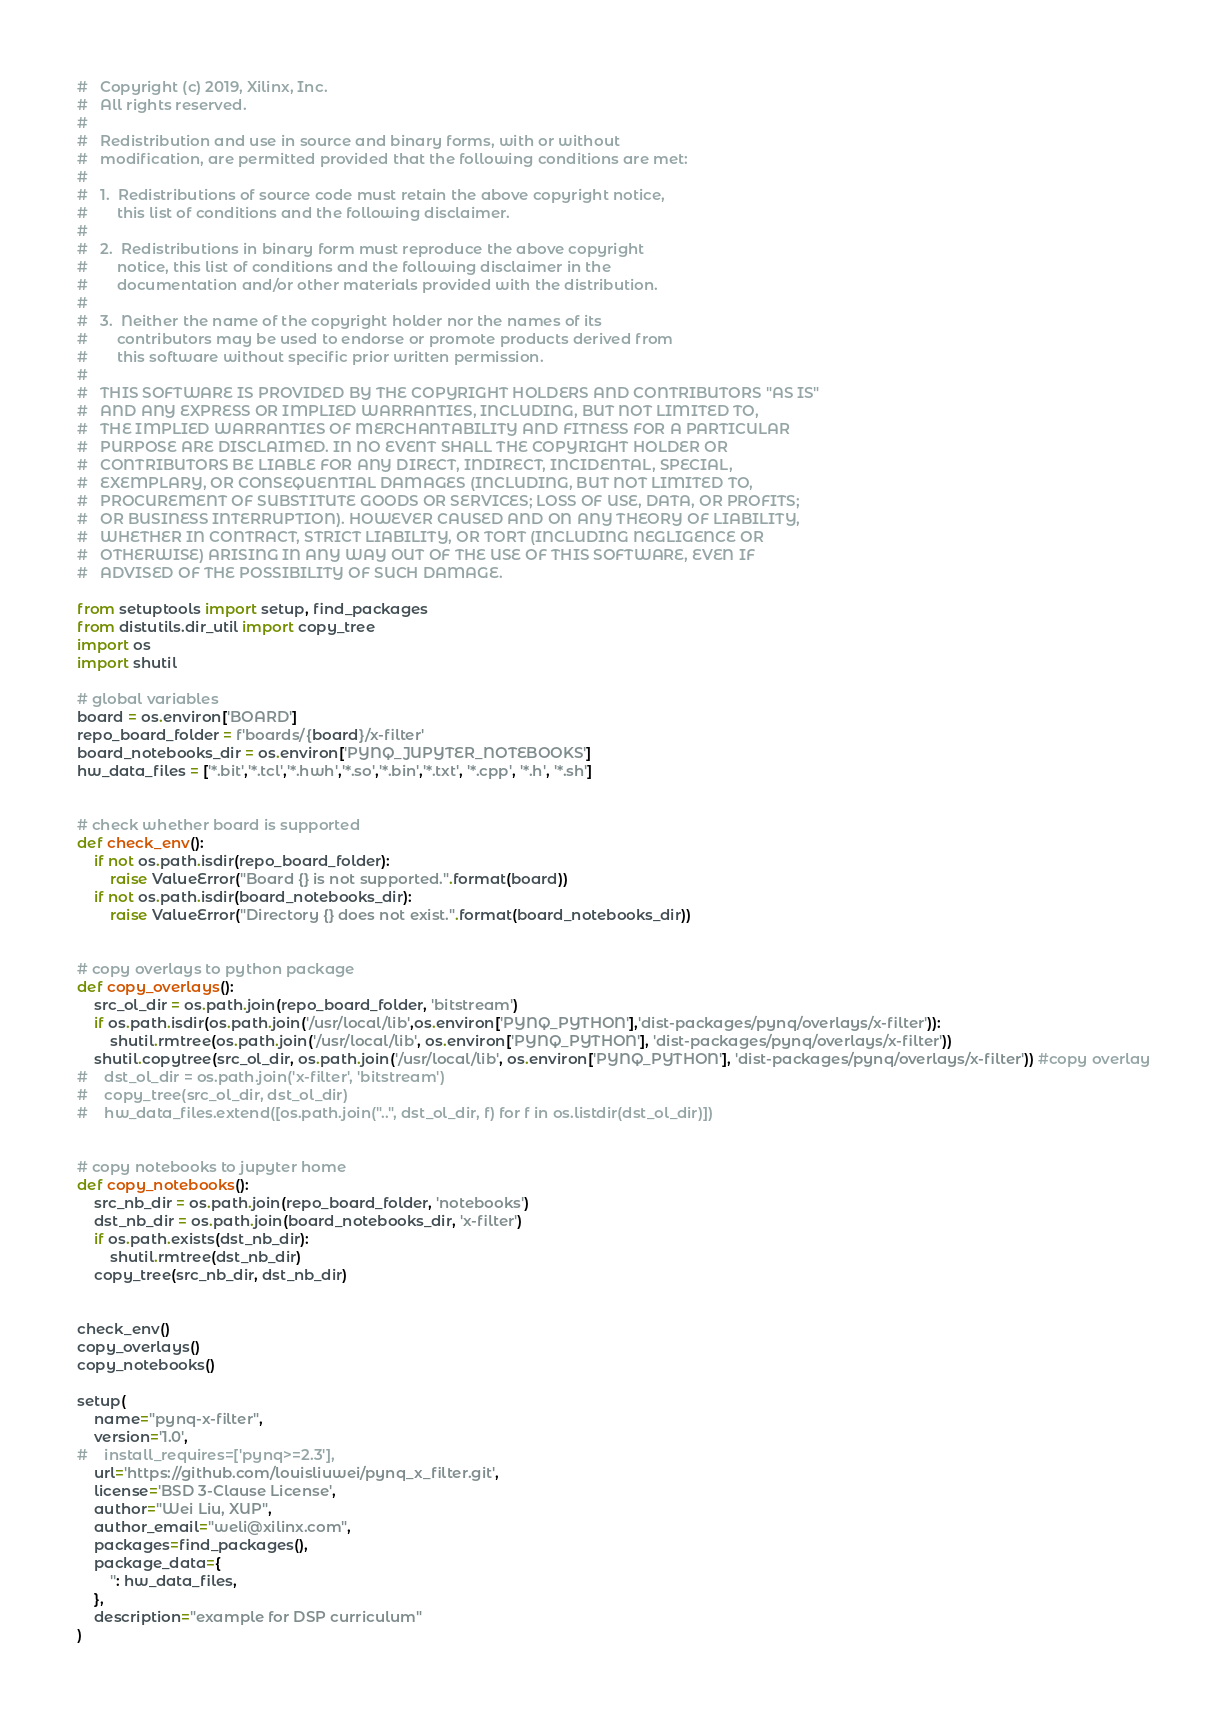Convert code to text. <code><loc_0><loc_0><loc_500><loc_500><_Python_>#   Copyright (c) 2019, Xilinx, Inc.
#   All rights reserved.
# 
#   Redistribution and use in source and binary forms, with or without 
#   modification, are permitted provided that the following conditions are met:
#
#   1.  Redistributions of source code must retain the above copyright notice, 
#       this list of conditions and the following disclaimer.
#
#   2.  Redistributions in binary form must reproduce the above copyright 
#       notice, this list of conditions and the following disclaimer in the 
#       documentation and/or other materials provided with the distribution.
#
#   3.  Neither the name of the copyright holder nor the names of its 
#       contributors may be used to endorse or promote products derived from 
#       this software without specific prior written permission.
#
#   THIS SOFTWARE IS PROVIDED BY THE COPYRIGHT HOLDERS AND CONTRIBUTORS "AS IS"
#   AND ANY EXPRESS OR IMPLIED WARRANTIES, INCLUDING, BUT NOT LIMITED TO, 
#   THE IMPLIED WARRANTIES OF MERCHANTABILITY AND FITNESS FOR A PARTICULAR 
#   PURPOSE ARE DISCLAIMED. IN NO EVENT SHALL THE COPYRIGHT HOLDER OR 
#   CONTRIBUTORS BE LIABLE FOR ANY DIRECT, INDIRECT, INCIDENTAL, SPECIAL, 
#   EXEMPLARY, OR CONSEQUENTIAL DAMAGES (INCLUDING, BUT NOT LIMITED TO, 
#   PROCUREMENT OF SUBSTITUTE GOODS OR SERVICES; LOSS OF USE, DATA, OR PROFITS;
#   OR BUSINESS INTERRUPTION). HOWEVER CAUSED AND ON ANY THEORY OF LIABILITY, 
#   WHETHER IN CONTRACT, STRICT LIABILITY, OR TORT (INCLUDING NEGLIGENCE OR 
#   OTHERWISE) ARISING IN ANY WAY OUT OF THE USE OF THIS SOFTWARE, EVEN IF 
#   ADVISED OF THE POSSIBILITY OF SUCH DAMAGE.

from setuptools import setup, find_packages
from distutils.dir_util import copy_tree
import os
import shutil

# global variables
board = os.environ['BOARD']
repo_board_folder = f'boards/{board}/x-filter'
board_notebooks_dir = os.environ['PYNQ_JUPYTER_NOTEBOOKS']
hw_data_files = ['*.bit','*.tcl','*.hwh','*.so','*.bin','*.txt', '*.cpp', '*.h', '*.sh']


# check whether board is supported
def check_env():
    if not os.path.isdir(repo_board_folder):
        raise ValueError("Board {} is not supported.".format(board))
    if not os.path.isdir(board_notebooks_dir):
        raise ValueError("Directory {} does not exist.".format(board_notebooks_dir))


# copy overlays to python package
def copy_overlays():
    src_ol_dir = os.path.join(repo_board_folder, 'bitstream')
    if os.path.isdir(os.path.join('/usr/local/lib',os.environ['PYNQ_PYTHON'],'dist-packages/pynq/overlays/x-filter')):
        shutil.rmtree(os.path.join('/usr/local/lib', os.environ['PYNQ_PYTHON'], 'dist-packages/pynq/overlays/x-filter'))
    shutil.copytree(src_ol_dir, os.path.join('/usr/local/lib', os.environ['PYNQ_PYTHON'], 'dist-packages/pynq/overlays/x-filter')) #copy overlay
#    dst_ol_dir = os.path.join('x-filter', 'bitstream')
#    copy_tree(src_ol_dir, dst_ol_dir)
#    hw_data_files.extend([os.path.join("..", dst_ol_dir, f) for f in os.listdir(dst_ol_dir)])


# copy notebooks to jupyter home
def copy_notebooks():
    src_nb_dir = os.path.join(repo_board_folder, 'notebooks')
    dst_nb_dir = os.path.join(board_notebooks_dir, 'x-filter')
    if os.path.exists(dst_nb_dir):
        shutil.rmtree(dst_nb_dir)
    copy_tree(src_nb_dir, dst_nb_dir)


check_env()
copy_overlays()
copy_notebooks()

setup(
    name="pynq-x-filter",
    version='1.0',
#    install_requires=['pynq>=2.3'],
    url='https://github.com/louisliuwei/pynq_x_filter.git',
    license='BSD 3-Clause License',
    author="Wei Liu, XUP",
    author_email="weli@xilinx.com",
    packages=find_packages(),
    package_data={
        '': hw_data_files,
    },
    description="example for DSP curriculum"
)
</code> 